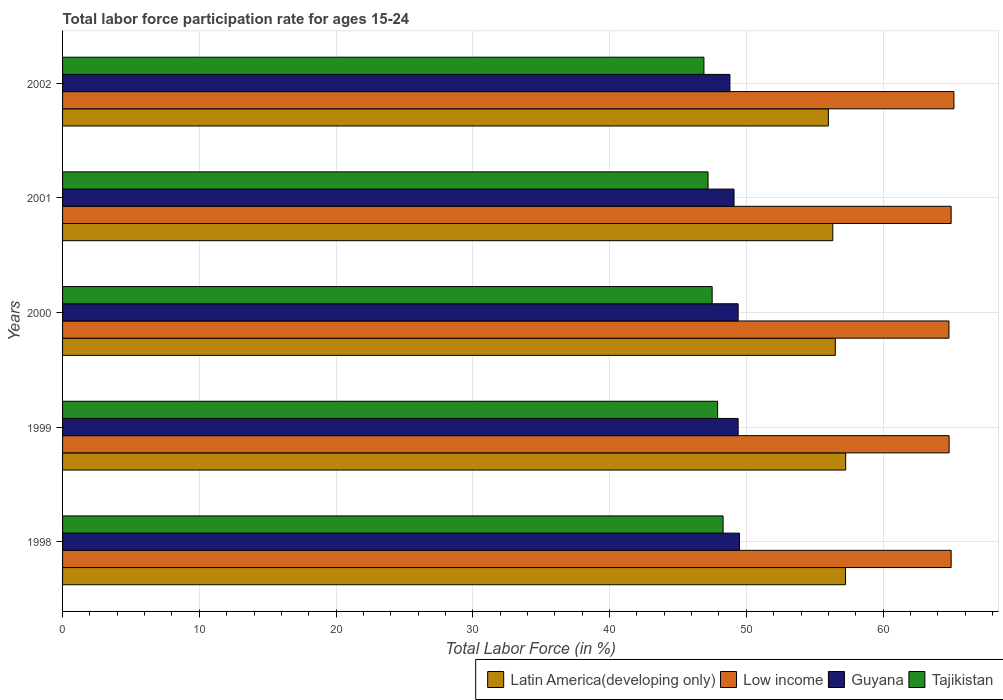How many different coloured bars are there?
Ensure brevity in your answer.  4. How many groups of bars are there?
Offer a very short reply. 5. How many bars are there on the 1st tick from the top?
Offer a very short reply. 4. How many bars are there on the 1st tick from the bottom?
Keep it short and to the point. 4. What is the labor force participation rate in Low income in 2000?
Offer a very short reply. 64.82. Across all years, what is the maximum labor force participation rate in Low income?
Keep it short and to the point. 65.18. Across all years, what is the minimum labor force participation rate in Tajikistan?
Your response must be concise. 46.9. In which year was the labor force participation rate in Low income minimum?
Your answer should be very brief. 2000. What is the total labor force participation rate in Latin America(developing only) in the graph?
Provide a succinct answer. 283.34. What is the difference between the labor force participation rate in Guyana in 2000 and that in 2001?
Your answer should be very brief. 0.3. What is the difference between the labor force participation rate in Tajikistan in 1998 and the labor force participation rate in Low income in 2001?
Make the answer very short. -16.68. What is the average labor force participation rate in Latin America(developing only) per year?
Your answer should be very brief. 56.67. In the year 1998, what is the difference between the labor force participation rate in Guyana and labor force participation rate in Low income?
Ensure brevity in your answer.  -15.48. In how many years, is the labor force participation rate in Guyana greater than 48 %?
Give a very brief answer. 5. What is the ratio of the labor force participation rate in Guyana in 2001 to that in 2002?
Provide a succinct answer. 1.01. Is the labor force participation rate in Tajikistan in 2000 less than that in 2002?
Provide a short and direct response. No. Is the difference between the labor force participation rate in Guyana in 2001 and 2002 greater than the difference between the labor force participation rate in Low income in 2001 and 2002?
Your answer should be compact. Yes. What is the difference between the highest and the second highest labor force participation rate in Tajikistan?
Offer a very short reply. 0.4. What is the difference between the highest and the lowest labor force participation rate in Tajikistan?
Your answer should be compact. 1.4. In how many years, is the labor force participation rate in Tajikistan greater than the average labor force participation rate in Tajikistan taken over all years?
Provide a short and direct response. 2. Is the sum of the labor force participation rate in Tajikistan in 2000 and 2002 greater than the maximum labor force participation rate in Guyana across all years?
Make the answer very short. Yes. What does the 3rd bar from the top in 1999 represents?
Your answer should be compact. Low income. How are the legend labels stacked?
Offer a terse response. Horizontal. What is the title of the graph?
Offer a terse response. Total labor force participation rate for ages 15-24. Does "High income: OECD" appear as one of the legend labels in the graph?
Offer a terse response. No. What is the label or title of the X-axis?
Keep it short and to the point. Total Labor Force (in %). What is the label or title of the Y-axis?
Give a very brief answer. Years. What is the Total Labor Force (in %) of Latin America(developing only) in 1998?
Your response must be concise. 57.25. What is the Total Labor Force (in %) of Low income in 1998?
Keep it short and to the point. 64.98. What is the Total Labor Force (in %) in Guyana in 1998?
Your answer should be compact. 49.5. What is the Total Labor Force (in %) of Tajikistan in 1998?
Keep it short and to the point. 48.3. What is the Total Labor Force (in %) in Latin America(developing only) in 1999?
Give a very brief answer. 57.26. What is the Total Labor Force (in %) of Low income in 1999?
Provide a short and direct response. 64.83. What is the Total Labor Force (in %) of Guyana in 1999?
Make the answer very short. 49.4. What is the Total Labor Force (in %) in Tajikistan in 1999?
Provide a short and direct response. 47.9. What is the Total Labor Force (in %) in Latin America(developing only) in 2000?
Your response must be concise. 56.51. What is the Total Labor Force (in %) in Low income in 2000?
Offer a terse response. 64.82. What is the Total Labor Force (in %) of Guyana in 2000?
Provide a succinct answer. 49.4. What is the Total Labor Force (in %) of Tajikistan in 2000?
Make the answer very short. 47.5. What is the Total Labor Force (in %) in Latin America(developing only) in 2001?
Ensure brevity in your answer.  56.32. What is the Total Labor Force (in %) of Low income in 2001?
Ensure brevity in your answer.  64.98. What is the Total Labor Force (in %) in Guyana in 2001?
Provide a succinct answer. 49.1. What is the Total Labor Force (in %) of Tajikistan in 2001?
Offer a very short reply. 47.2. What is the Total Labor Force (in %) of Latin America(developing only) in 2002?
Keep it short and to the point. 56. What is the Total Labor Force (in %) of Low income in 2002?
Ensure brevity in your answer.  65.18. What is the Total Labor Force (in %) of Guyana in 2002?
Provide a succinct answer. 48.8. What is the Total Labor Force (in %) of Tajikistan in 2002?
Keep it short and to the point. 46.9. Across all years, what is the maximum Total Labor Force (in %) in Latin America(developing only)?
Give a very brief answer. 57.26. Across all years, what is the maximum Total Labor Force (in %) in Low income?
Your answer should be very brief. 65.18. Across all years, what is the maximum Total Labor Force (in %) of Guyana?
Your response must be concise. 49.5. Across all years, what is the maximum Total Labor Force (in %) in Tajikistan?
Ensure brevity in your answer.  48.3. Across all years, what is the minimum Total Labor Force (in %) of Latin America(developing only)?
Ensure brevity in your answer.  56. Across all years, what is the minimum Total Labor Force (in %) in Low income?
Provide a short and direct response. 64.82. Across all years, what is the minimum Total Labor Force (in %) of Guyana?
Keep it short and to the point. 48.8. Across all years, what is the minimum Total Labor Force (in %) of Tajikistan?
Your answer should be compact. 46.9. What is the total Total Labor Force (in %) in Latin America(developing only) in the graph?
Offer a terse response. 283.34. What is the total Total Labor Force (in %) of Low income in the graph?
Your response must be concise. 324.78. What is the total Total Labor Force (in %) of Guyana in the graph?
Offer a very short reply. 246.2. What is the total Total Labor Force (in %) in Tajikistan in the graph?
Your answer should be very brief. 237.8. What is the difference between the Total Labor Force (in %) in Latin America(developing only) in 1998 and that in 1999?
Make the answer very short. -0.02. What is the difference between the Total Labor Force (in %) of Low income in 1998 and that in 1999?
Keep it short and to the point. 0.15. What is the difference between the Total Labor Force (in %) in Guyana in 1998 and that in 1999?
Give a very brief answer. 0.1. What is the difference between the Total Labor Force (in %) in Tajikistan in 1998 and that in 1999?
Provide a succinct answer. 0.4. What is the difference between the Total Labor Force (in %) in Latin America(developing only) in 1998 and that in 2000?
Make the answer very short. 0.74. What is the difference between the Total Labor Force (in %) of Low income in 1998 and that in 2000?
Your response must be concise. 0.16. What is the difference between the Total Labor Force (in %) of Tajikistan in 1998 and that in 2000?
Ensure brevity in your answer.  0.8. What is the difference between the Total Labor Force (in %) in Latin America(developing only) in 1998 and that in 2001?
Provide a succinct answer. 0.93. What is the difference between the Total Labor Force (in %) of Low income in 1998 and that in 2001?
Offer a terse response. -0. What is the difference between the Total Labor Force (in %) of Guyana in 1998 and that in 2001?
Provide a succinct answer. 0.4. What is the difference between the Total Labor Force (in %) in Latin America(developing only) in 1998 and that in 2002?
Your answer should be very brief. 1.25. What is the difference between the Total Labor Force (in %) in Low income in 1998 and that in 2002?
Provide a short and direct response. -0.2. What is the difference between the Total Labor Force (in %) of Guyana in 1998 and that in 2002?
Provide a succinct answer. 0.7. What is the difference between the Total Labor Force (in %) in Latin America(developing only) in 1999 and that in 2000?
Provide a short and direct response. 0.76. What is the difference between the Total Labor Force (in %) of Low income in 1999 and that in 2000?
Provide a short and direct response. 0.01. What is the difference between the Total Labor Force (in %) of Tajikistan in 1999 and that in 2000?
Provide a short and direct response. 0.4. What is the difference between the Total Labor Force (in %) in Latin America(developing only) in 1999 and that in 2001?
Your response must be concise. 0.94. What is the difference between the Total Labor Force (in %) in Low income in 1999 and that in 2001?
Ensure brevity in your answer.  -0.15. What is the difference between the Total Labor Force (in %) in Latin America(developing only) in 1999 and that in 2002?
Keep it short and to the point. 1.27. What is the difference between the Total Labor Force (in %) in Low income in 1999 and that in 2002?
Your answer should be very brief. -0.35. What is the difference between the Total Labor Force (in %) in Guyana in 1999 and that in 2002?
Offer a terse response. 0.6. What is the difference between the Total Labor Force (in %) in Latin America(developing only) in 2000 and that in 2001?
Your answer should be compact. 0.18. What is the difference between the Total Labor Force (in %) of Low income in 2000 and that in 2001?
Ensure brevity in your answer.  -0.16. What is the difference between the Total Labor Force (in %) in Tajikistan in 2000 and that in 2001?
Make the answer very short. 0.3. What is the difference between the Total Labor Force (in %) in Latin America(developing only) in 2000 and that in 2002?
Provide a succinct answer. 0.51. What is the difference between the Total Labor Force (in %) in Low income in 2000 and that in 2002?
Offer a terse response. -0.36. What is the difference between the Total Labor Force (in %) of Guyana in 2000 and that in 2002?
Offer a terse response. 0.6. What is the difference between the Total Labor Force (in %) of Tajikistan in 2000 and that in 2002?
Keep it short and to the point. 0.6. What is the difference between the Total Labor Force (in %) of Latin America(developing only) in 2001 and that in 2002?
Offer a very short reply. 0.32. What is the difference between the Total Labor Force (in %) of Low income in 2001 and that in 2002?
Give a very brief answer. -0.2. What is the difference between the Total Labor Force (in %) in Latin America(developing only) in 1998 and the Total Labor Force (in %) in Low income in 1999?
Offer a very short reply. -7.58. What is the difference between the Total Labor Force (in %) of Latin America(developing only) in 1998 and the Total Labor Force (in %) of Guyana in 1999?
Offer a very short reply. 7.85. What is the difference between the Total Labor Force (in %) of Latin America(developing only) in 1998 and the Total Labor Force (in %) of Tajikistan in 1999?
Provide a succinct answer. 9.35. What is the difference between the Total Labor Force (in %) of Low income in 1998 and the Total Labor Force (in %) of Guyana in 1999?
Keep it short and to the point. 15.58. What is the difference between the Total Labor Force (in %) in Low income in 1998 and the Total Labor Force (in %) in Tajikistan in 1999?
Give a very brief answer. 17.08. What is the difference between the Total Labor Force (in %) in Latin America(developing only) in 1998 and the Total Labor Force (in %) in Low income in 2000?
Offer a terse response. -7.57. What is the difference between the Total Labor Force (in %) of Latin America(developing only) in 1998 and the Total Labor Force (in %) of Guyana in 2000?
Your answer should be compact. 7.85. What is the difference between the Total Labor Force (in %) of Latin America(developing only) in 1998 and the Total Labor Force (in %) of Tajikistan in 2000?
Provide a succinct answer. 9.75. What is the difference between the Total Labor Force (in %) of Low income in 1998 and the Total Labor Force (in %) of Guyana in 2000?
Your answer should be compact. 15.58. What is the difference between the Total Labor Force (in %) in Low income in 1998 and the Total Labor Force (in %) in Tajikistan in 2000?
Your response must be concise. 17.48. What is the difference between the Total Labor Force (in %) in Guyana in 1998 and the Total Labor Force (in %) in Tajikistan in 2000?
Provide a succinct answer. 2. What is the difference between the Total Labor Force (in %) in Latin America(developing only) in 1998 and the Total Labor Force (in %) in Low income in 2001?
Make the answer very short. -7.73. What is the difference between the Total Labor Force (in %) of Latin America(developing only) in 1998 and the Total Labor Force (in %) of Guyana in 2001?
Keep it short and to the point. 8.15. What is the difference between the Total Labor Force (in %) of Latin America(developing only) in 1998 and the Total Labor Force (in %) of Tajikistan in 2001?
Your response must be concise. 10.05. What is the difference between the Total Labor Force (in %) in Low income in 1998 and the Total Labor Force (in %) in Guyana in 2001?
Offer a terse response. 15.88. What is the difference between the Total Labor Force (in %) of Low income in 1998 and the Total Labor Force (in %) of Tajikistan in 2001?
Your answer should be compact. 17.78. What is the difference between the Total Labor Force (in %) in Guyana in 1998 and the Total Labor Force (in %) in Tajikistan in 2001?
Give a very brief answer. 2.3. What is the difference between the Total Labor Force (in %) of Latin America(developing only) in 1998 and the Total Labor Force (in %) of Low income in 2002?
Give a very brief answer. -7.93. What is the difference between the Total Labor Force (in %) of Latin America(developing only) in 1998 and the Total Labor Force (in %) of Guyana in 2002?
Your response must be concise. 8.45. What is the difference between the Total Labor Force (in %) of Latin America(developing only) in 1998 and the Total Labor Force (in %) of Tajikistan in 2002?
Offer a very short reply. 10.35. What is the difference between the Total Labor Force (in %) of Low income in 1998 and the Total Labor Force (in %) of Guyana in 2002?
Provide a succinct answer. 16.18. What is the difference between the Total Labor Force (in %) of Low income in 1998 and the Total Labor Force (in %) of Tajikistan in 2002?
Your answer should be very brief. 18.08. What is the difference between the Total Labor Force (in %) in Guyana in 1998 and the Total Labor Force (in %) in Tajikistan in 2002?
Provide a succinct answer. 2.6. What is the difference between the Total Labor Force (in %) of Latin America(developing only) in 1999 and the Total Labor Force (in %) of Low income in 2000?
Offer a very short reply. -7.55. What is the difference between the Total Labor Force (in %) of Latin America(developing only) in 1999 and the Total Labor Force (in %) of Guyana in 2000?
Provide a succinct answer. 7.86. What is the difference between the Total Labor Force (in %) in Latin America(developing only) in 1999 and the Total Labor Force (in %) in Tajikistan in 2000?
Your response must be concise. 9.76. What is the difference between the Total Labor Force (in %) of Low income in 1999 and the Total Labor Force (in %) of Guyana in 2000?
Offer a very short reply. 15.43. What is the difference between the Total Labor Force (in %) of Low income in 1999 and the Total Labor Force (in %) of Tajikistan in 2000?
Keep it short and to the point. 17.33. What is the difference between the Total Labor Force (in %) of Latin America(developing only) in 1999 and the Total Labor Force (in %) of Low income in 2001?
Offer a very short reply. -7.71. What is the difference between the Total Labor Force (in %) of Latin America(developing only) in 1999 and the Total Labor Force (in %) of Guyana in 2001?
Ensure brevity in your answer.  8.16. What is the difference between the Total Labor Force (in %) in Latin America(developing only) in 1999 and the Total Labor Force (in %) in Tajikistan in 2001?
Provide a succinct answer. 10.06. What is the difference between the Total Labor Force (in %) of Low income in 1999 and the Total Labor Force (in %) of Guyana in 2001?
Make the answer very short. 15.73. What is the difference between the Total Labor Force (in %) of Low income in 1999 and the Total Labor Force (in %) of Tajikistan in 2001?
Keep it short and to the point. 17.63. What is the difference between the Total Labor Force (in %) of Latin America(developing only) in 1999 and the Total Labor Force (in %) of Low income in 2002?
Ensure brevity in your answer.  -7.91. What is the difference between the Total Labor Force (in %) in Latin America(developing only) in 1999 and the Total Labor Force (in %) in Guyana in 2002?
Make the answer very short. 8.46. What is the difference between the Total Labor Force (in %) of Latin America(developing only) in 1999 and the Total Labor Force (in %) of Tajikistan in 2002?
Ensure brevity in your answer.  10.36. What is the difference between the Total Labor Force (in %) of Low income in 1999 and the Total Labor Force (in %) of Guyana in 2002?
Make the answer very short. 16.03. What is the difference between the Total Labor Force (in %) in Low income in 1999 and the Total Labor Force (in %) in Tajikistan in 2002?
Keep it short and to the point. 17.93. What is the difference between the Total Labor Force (in %) of Guyana in 1999 and the Total Labor Force (in %) of Tajikistan in 2002?
Offer a very short reply. 2.5. What is the difference between the Total Labor Force (in %) of Latin America(developing only) in 2000 and the Total Labor Force (in %) of Low income in 2001?
Your answer should be very brief. -8.47. What is the difference between the Total Labor Force (in %) of Latin America(developing only) in 2000 and the Total Labor Force (in %) of Guyana in 2001?
Your answer should be compact. 7.41. What is the difference between the Total Labor Force (in %) of Latin America(developing only) in 2000 and the Total Labor Force (in %) of Tajikistan in 2001?
Give a very brief answer. 9.31. What is the difference between the Total Labor Force (in %) in Low income in 2000 and the Total Labor Force (in %) in Guyana in 2001?
Provide a succinct answer. 15.72. What is the difference between the Total Labor Force (in %) in Low income in 2000 and the Total Labor Force (in %) in Tajikistan in 2001?
Your answer should be compact. 17.62. What is the difference between the Total Labor Force (in %) in Guyana in 2000 and the Total Labor Force (in %) in Tajikistan in 2001?
Your response must be concise. 2.2. What is the difference between the Total Labor Force (in %) in Latin America(developing only) in 2000 and the Total Labor Force (in %) in Low income in 2002?
Give a very brief answer. -8.67. What is the difference between the Total Labor Force (in %) in Latin America(developing only) in 2000 and the Total Labor Force (in %) in Guyana in 2002?
Offer a very short reply. 7.71. What is the difference between the Total Labor Force (in %) of Latin America(developing only) in 2000 and the Total Labor Force (in %) of Tajikistan in 2002?
Give a very brief answer. 9.61. What is the difference between the Total Labor Force (in %) of Low income in 2000 and the Total Labor Force (in %) of Guyana in 2002?
Offer a very short reply. 16.02. What is the difference between the Total Labor Force (in %) of Low income in 2000 and the Total Labor Force (in %) of Tajikistan in 2002?
Ensure brevity in your answer.  17.92. What is the difference between the Total Labor Force (in %) in Latin America(developing only) in 2001 and the Total Labor Force (in %) in Low income in 2002?
Your answer should be very brief. -8.86. What is the difference between the Total Labor Force (in %) of Latin America(developing only) in 2001 and the Total Labor Force (in %) of Guyana in 2002?
Your response must be concise. 7.52. What is the difference between the Total Labor Force (in %) of Latin America(developing only) in 2001 and the Total Labor Force (in %) of Tajikistan in 2002?
Offer a very short reply. 9.42. What is the difference between the Total Labor Force (in %) in Low income in 2001 and the Total Labor Force (in %) in Guyana in 2002?
Provide a succinct answer. 16.18. What is the difference between the Total Labor Force (in %) of Low income in 2001 and the Total Labor Force (in %) of Tajikistan in 2002?
Keep it short and to the point. 18.08. What is the average Total Labor Force (in %) of Latin America(developing only) per year?
Your response must be concise. 56.67. What is the average Total Labor Force (in %) of Low income per year?
Give a very brief answer. 64.96. What is the average Total Labor Force (in %) in Guyana per year?
Ensure brevity in your answer.  49.24. What is the average Total Labor Force (in %) of Tajikistan per year?
Make the answer very short. 47.56. In the year 1998, what is the difference between the Total Labor Force (in %) in Latin America(developing only) and Total Labor Force (in %) in Low income?
Ensure brevity in your answer.  -7.73. In the year 1998, what is the difference between the Total Labor Force (in %) of Latin America(developing only) and Total Labor Force (in %) of Guyana?
Offer a very short reply. 7.75. In the year 1998, what is the difference between the Total Labor Force (in %) in Latin America(developing only) and Total Labor Force (in %) in Tajikistan?
Give a very brief answer. 8.95. In the year 1998, what is the difference between the Total Labor Force (in %) in Low income and Total Labor Force (in %) in Guyana?
Offer a very short reply. 15.48. In the year 1998, what is the difference between the Total Labor Force (in %) of Low income and Total Labor Force (in %) of Tajikistan?
Provide a succinct answer. 16.68. In the year 1999, what is the difference between the Total Labor Force (in %) of Latin America(developing only) and Total Labor Force (in %) of Low income?
Offer a terse response. -7.56. In the year 1999, what is the difference between the Total Labor Force (in %) of Latin America(developing only) and Total Labor Force (in %) of Guyana?
Give a very brief answer. 7.86. In the year 1999, what is the difference between the Total Labor Force (in %) in Latin America(developing only) and Total Labor Force (in %) in Tajikistan?
Make the answer very short. 9.36. In the year 1999, what is the difference between the Total Labor Force (in %) of Low income and Total Labor Force (in %) of Guyana?
Make the answer very short. 15.43. In the year 1999, what is the difference between the Total Labor Force (in %) of Low income and Total Labor Force (in %) of Tajikistan?
Your answer should be compact. 16.93. In the year 1999, what is the difference between the Total Labor Force (in %) of Guyana and Total Labor Force (in %) of Tajikistan?
Provide a succinct answer. 1.5. In the year 2000, what is the difference between the Total Labor Force (in %) of Latin America(developing only) and Total Labor Force (in %) of Low income?
Keep it short and to the point. -8.31. In the year 2000, what is the difference between the Total Labor Force (in %) of Latin America(developing only) and Total Labor Force (in %) of Guyana?
Your answer should be compact. 7.11. In the year 2000, what is the difference between the Total Labor Force (in %) in Latin America(developing only) and Total Labor Force (in %) in Tajikistan?
Offer a very short reply. 9.01. In the year 2000, what is the difference between the Total Labor Force (in %) of Low income and Total Labor Force (in %) of Guyana?
Offer a terse response. 15.42. In the year 2000, what is the difference between the Total Labor Force (in %) in Low income and Total Labor Force (in %) in Tajikistan?
Your answer should be very brief. 17.32. In the year 2000, what is the difference between the Total Labor Force (in %) of Guyana and Total Labor Force (in %) of Tajikistan?
Provide a short and direct response. 1.9. In the year 2001, what is the difference between the Total Labor Force (in %) of Latin America(developing only) and Total Labor Force (in %) of Low income?
Provide a short and direct response. -8.65. In the year 2001, what is the difference between the Total Labor Force (in %) of Latin America(developing only) and Total Labor Force (in %) of Guyana?
Give a very brief answer. 7.22. In the year 2001, what is the difference between the Total Labor Force (in %) of Latin America(developing only) and Total Labor Force (in %) of Tajikistan?
Your response must be concise. 9.12. In the year 2001, what is the difference between the Total Labor Force (in %) of Low income and Total Labor Force (in %) of Guyana?
Your response must be concise. 15.88. In the year 2001, what is the difference between the Total Labor Force (in %) in Low income and Total Labor Force (in %) in Tajikistan?
Give a very brief answer. 17.78. In the year 2001, what is the difference between the Total Labor Force (in %) in Guyana and Total Labor Force (in %) in Tajikistan?
Offer a very short reply. 1.9. In the year 2002, what is the difference between the Total Labor Force (in %) of Latin America(developing only) and Total Labor Force (in %) of Low income?
Provide a short and direct response. -9.18. In the year 2002, what is the difference between the Total Labor Force (in %) of Latin America(developing only) and Total Labor Force (in %) of Guyana?
Give a very brief answer. 7.2. In the year 2002, what is the difference between the Total Labor Force (in %) in Latin America(developing only) and Total Labor Force (in %) in Tajikistan?
Ensure brevity in your answer.  9.1. In the year 2002, what is the difference between the Total Labor Force (in %) in Low income and Total Labor Force (in %) in Guyana?
Keep it short and to the point. 16.38. In the year 2002, what is the difference between the Total Labor Force (in %) in Low income and Total Labor Force (in %) in Tajikistan?
Your answer should be very brief. 18.28. In the year 2002, what is the difference between the Total Labor Force (in %) in Guyana and Total Labor Force (in %) in Tajikistan?
Ensure brevity in your answer.  1.9. What is the ratio of the Total Labor Force (in %) of Latin America(developing only) in 1998 to that in 1999?
Keep it short and to the point. 1. What is the ratio of the Total Labor Force (in %) in Guyana in 1998 to that in 1999?
Your answer should be compact. 1. What is the ratio of the Total Labor Force (in %) in Tajikistan in 1998 to that in 1999?
Your answer should be compact. 1.01. What is the ratio of the Total Labor Force (in %) in Latin America(developing only) in 1998 to that in 2000?
Make the answer very short. 1.01. What is the ratio of the Total Labor Force (in %) in Guyana in 1998 to that in 2000?
Give a very brief answer. 1. What is the ratio of the Total Labor Force (in %) of Tajikistan in 1998 to that in 2000?
Give a very brief answer. 1.02. What is the ratio of the Total Labor Force (in %) in Latin America(developing only) in 1998 to that in 2001?
Your answer should be compact. 1.02. What is the ratio of the Total Labor Force (in %) in Guyana in 1998 to that in 2001?
Your answer should be compact. 1.01. What is the ratio of the Total Labor Force (in %) in Tajikistan in 1998 to that in 2001?
Offer a terse response. 1.02. What is the ratio of the Total Labor Force (in %) of Latin America(developing only) in 1998 to that in 2002?
Offer a very short reply. 1.02. What is the ratio of the Total Labor Force (in %) of Low income in 1998 to that in 2002?
Provide a short and direct response. 1. What is the ratio of the Total Labor Force (in %) of Guyana in 1998 to that in 2002?
Your response must be concise. 1.01. What is the ratio of the Total Labor Force (in %) of Tajikistan in 1998 to that in 2002?
Provide a succinct answer. 1.03. What is the ratio of the Total Labor Force (in %) of Latin America(developing only) in 1999 to that in 2000?
Your answer should be very brief. 1.01. What is the ratio of the Total Labor Force (in %) of Tajikistan in 1999 to that in 2000?
Make the answer very short. 1.01. What is the ratio of the Total Labor Force (in %) of Latin America(developing only) in 1999 to that in 2001?
Make the answer very short. 1.02. What is the ratio of the Total Labor Force (in %) in Low income in 1999 to that in 2001?
Keep it short and to the point. 1. What is the ratio of the Total Labor Force (in %) in Guyana in 1999 to that in 2001?
Make the answer very short. 1.01. What is the ratio of the Total Labor Force (in %) in Tajikistan in 1999 to that in 2001?
Ensure brevity in your answer.  1.01. What is the ratio of the Total Labor Force (in %) in Latin America(developing only) in 1999 to that in 2002?
Your answer should be very brief. 1.02. What is the ratio of the Total Labor Force (in %) in Low income in 1999 to that in 2002?
Keep it short and to the point. 0.99. What is the ratio of the Total Labor Force (in %) in Guyana in 1999 to that in 2002?
Provide a short and direct response. 1.01. What is the ratio of the Total Labor Force (in %) in Tajikistan in 1999 to that in 2002?
Make the answer very short. 1.02. What is the ratio of the Total Labor Force (in %) of Latin America(developing only) in 2000 to that in 2001?
Offer a terse response. 1. What is the ratio of the Total Labor Force (in %) of Guyana in 2000 to that in 2001?
Your response must be concise. 1.01. What is the ratio of the Total Labor Force (in %) in Tajikistan in 2000 to that in 2001?
Make the answer very short. 1.01. What is the ratio of the Total Labor Force (in %) of Latin America(developing only) in 2000 to that in 2002?
Give a very brief answer. 1.01. What is the ratio of the Total Labor Force (in %) of Low income in 2000 to that in 2002?
Your response must be concise. 0.99. What is the ratio of the Total Labor Force (in %) of Guyana in 2000 to that in 2002?
Offer a terse response. 1.01. What is the ratio of the Total Labor Force (in %) in Tajikistan in 2000 to that in 2002?
Offer a very short reply. 1.01. What is the ratio of the Total Labor Force (in %) of Low income in 2001 to that in 2002?
Keep it short and to the point. 1. What is the ratio of the Total Labor Force (in %) of Tajikistan in 2001 to that in 2002?
Your response must be concise. 1.01. What is the difference between the highest and the second highest Total Labor Force (in %) in Latin America(developing only)?
Keep it short and to the point. 0.02. What is the difference between the highest and the second highest Total Labor Force (in %) in Low income?
Your response must be concise. 0.2. What is the difference between the highest and the second highest Total Labor Force (in %) in Guyana?
Offer a terse response. 0.1. What is the difference between the highest and the lowest Total Labor Force (in %) of Latin America(developing only)?
Give a very brief answer. 1.27. What is the difference between the highest and the lowest Total Labor Force (in %) of Low income?
Provide a succinct answer. 0.36. What is the difference between the highest and the lowest Total Labor Force (in %) of Guyana?
Make the answer very short. 0.7. 